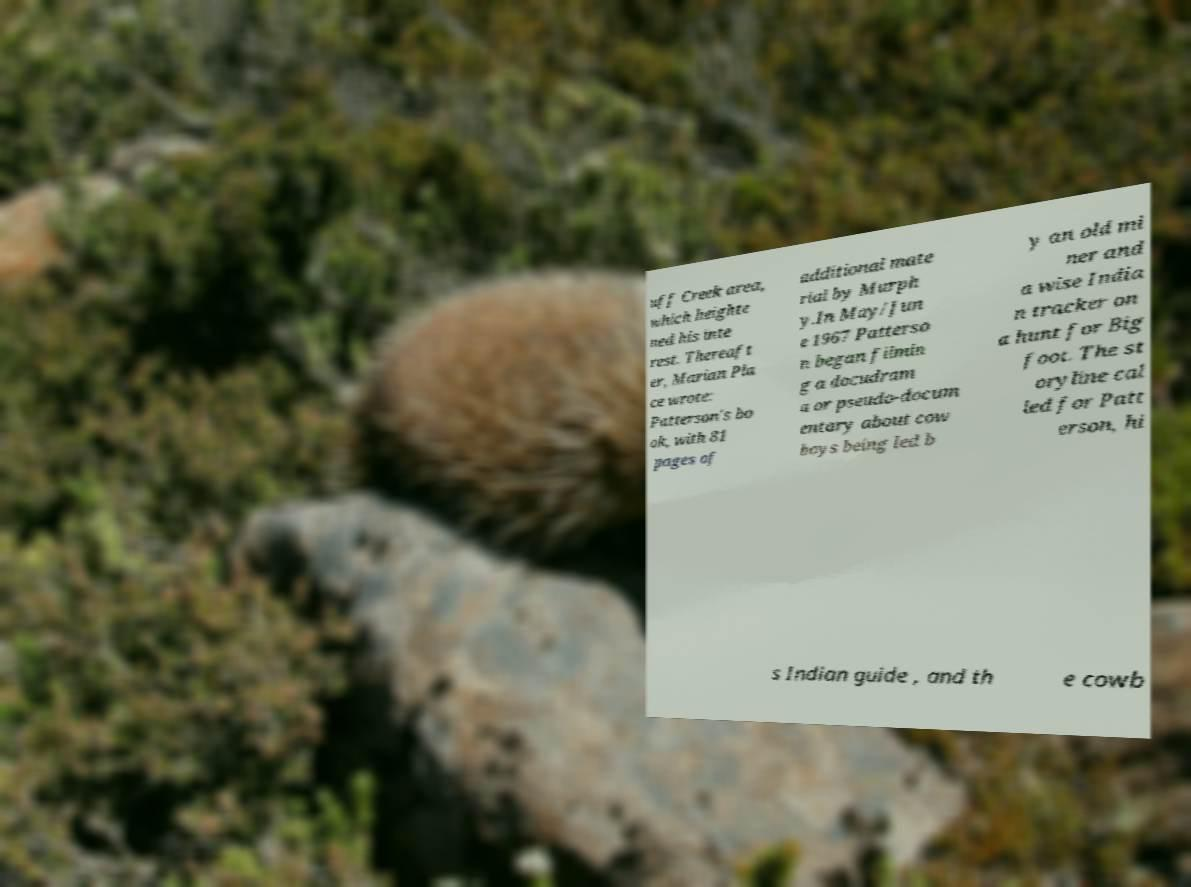I need the written content from this picture converted into text. Can you do that? uff Creek area, which heighte ned his inte rest. Thereaft er, Marian Pla ce wrote: Patterson's bo ok, with 81 pages of additional mate rial by Murph y.In May/Jun e 1967 Patterso n began filmin g a docudram a or pseudo-docum entary about cow boys being led b y an old mi ner and a wise India n tracker on a hunt for Big foot. The st oryline cal led for Patt erson, hi s Indian guide , and th e cowb 